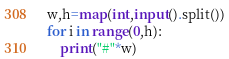<code> <loc_0><loc_0><loc_500><loc_500><_Python_>w,h=map(int,input().split())
for i in range(0,h):
    print("#"*w)</code> 